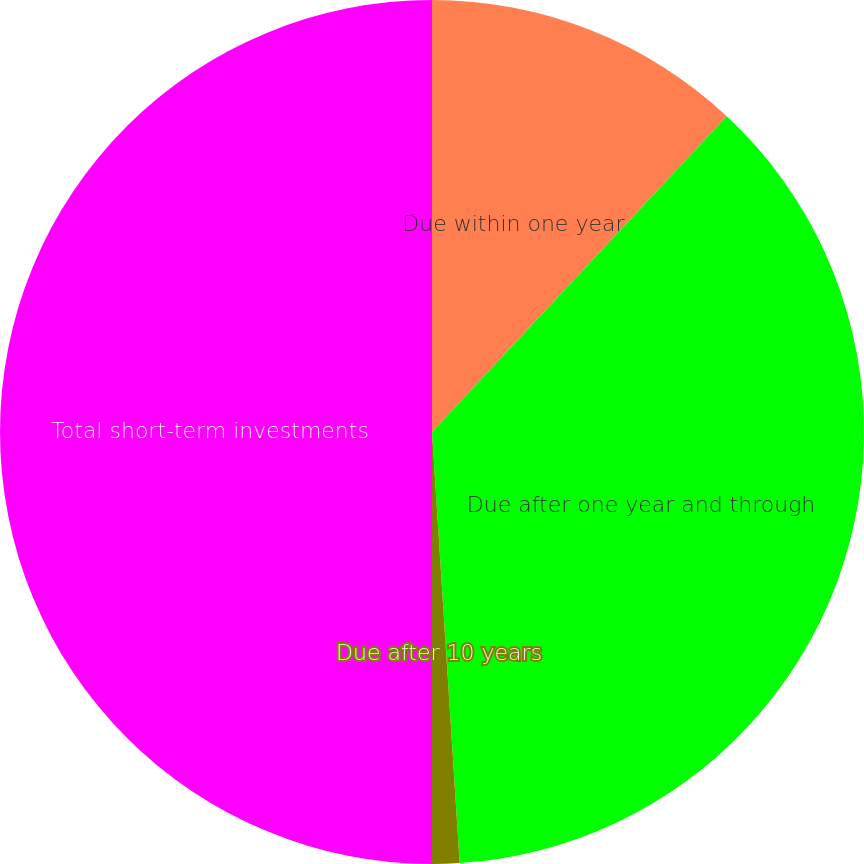Convert chart to OTSL. <chart><loc_0><loc_0><loc_500><loc_500><pie_chart><fcel>Due within one year<fcel>Due after one year and through<fcel>Due after 10 years<fcel>Total short-term investments<nl><fcel>11.95%<fcel>37.03%<fcel>1.02%<fcel>50.0%<nl></chart> 